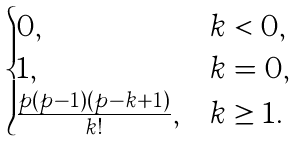Convert formula to latex. <formula><loc_0><loc_0><loc_500><loc_500>\begin{cases} 0 , & k < 0 , \\ 1 , & k = 0 , \\ \frac { p ( p - 1 ) \cdots ( p - k + 1 ) } { k ! } , & k \geq 1 . \end{cases}</formula> 